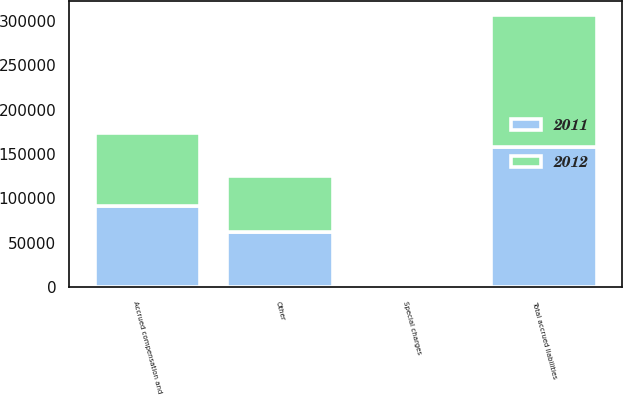Convert chart to OTSL. <chart><loc_0><loc_0><loc_500><loc_500><stacked_bar_chart><ecel><fcel>Accrued compensation and<fcel>Special charges<fcel>Other<fcel>Total accrued liabilities<nl><fcel>2012<fcel>82027<fcel>2993<fcel>63887<fcel>148907<nl><fcel>2011<fcel>91918<fcel>3876<fcel>61822<fcel>157616<nl></chart> 